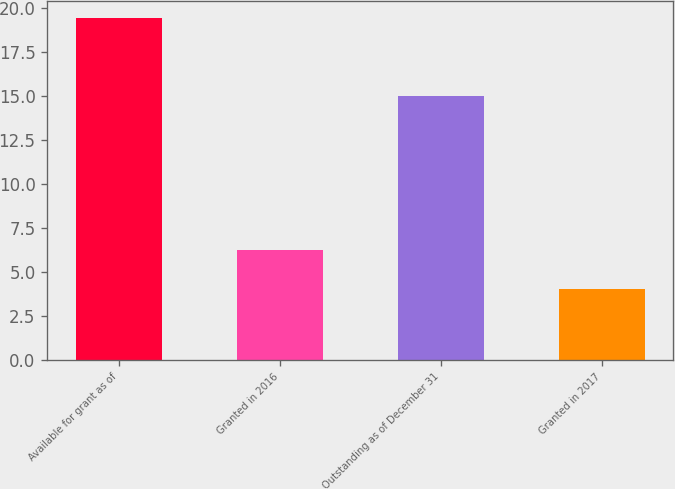Convert chart to OTSL. <chart><loc_0><loc_0><loc_500><loc_500><bar_chart><fcel>Available for grant as of<fcel>Granted in 2016<fcel>Outstanding as of December 31<fcel>Granted in 2017<nl><fcel>19.4<fcel>6.2<fcel>15<fcel>4<nl></chart> 